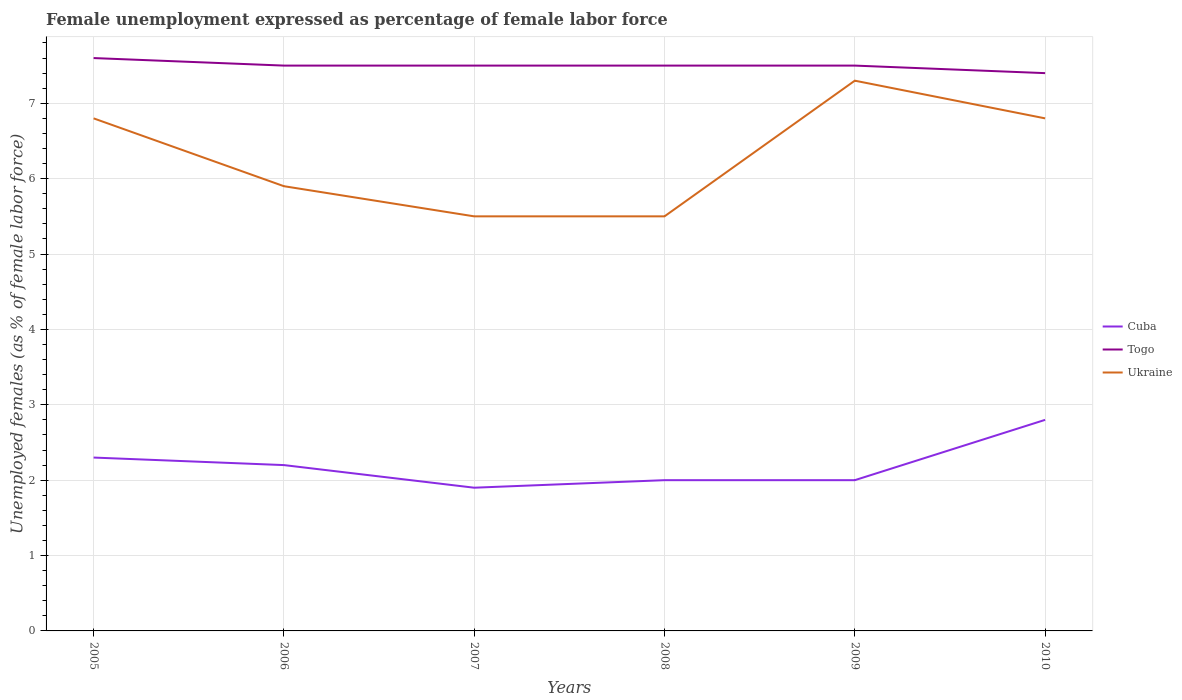How many different coloured lines are there?
Give a very brief answer. 3. Does the line corresponding to Ukraine intersect with the line corresponding to Cuba?
Provide a succinct answer. No. Is the number of lines equal to the number of legend labels?
Keep it short and to the point. Yes. What is the total unemployment in females in in Ukraine in the graph?
Give a very brief answer. 0.9. What is the difference between the highest and the second highest unemployment in females in in Togo?
Provide a succinct answer. 0.2. What is the difference between the highest and the lowest unemployment in females in in Cuba?
Your answer should be compact. 3. How many years are there in the graph?
Your answer should be very brief. 6. What is the difference between two consecutive major ticks on the Y-axis?
Give a very brief answer. 1. Does the graph contain any zero values?
Provide a short and direct response. No. Does the graph contain grids?
Provide a short and direct response. Yes. Where does the legend appear in the graph?
Provide a succinct answer. Center right. How many legend labels are there?
Offer a terse response. 3. How are the legend labels stacked?
Provide a short and direct response. Vertical. What is the title of the graph?
Offer a terse response. Female unemployment expressed as percentage of female labor force. Does "Brazil" appear as one of the legend labels in the graph?
Make the answer very short. No. What is the label or title of the X-axis?
Provide a succinct answer. Years. What is the label or title of the Y-axis?
Ensure brevity in your answer.  Unemployed females (as % of female labor force). What is the Unemployed females (as % of female labor force) in Cuba in 2005?
Make the answer very short. 2.3. What is the Unemployed females (as % of female labor force) of Togo in 2005?
Your response must be concise. 7.6. What is the Unemployed females (as % of female labor force) of Ukraine in 2005?
Keep it short and to the point. 6.8. What is the Unemployed females (as % of female labor force) in Cuba in 2006?
Provide a short and direct response. 2.2. What is the Unemployed females (as % of female labor force) in Ukraine in 2006?
Provide a succinct answer. 5.9. What is the Unemployed females (as % of female labor force) in Cuba in 2007?
Your response must be concise. 1.9. What is the Unemployed females (as % of female labor force) of Togo in 2007?
Offer a very short reply. 7.5. What is the Unemployed females (as % of female labor force) of Cuba in 2008?
Ensure brevity in your answer.  2. What is the Unemployed females (as % of female labor force) of Ukraine in 2008?
Ensure brevity in your answer.  5.5. What is the Unemployed females (as % of female labor force) of Cuba in 2009?
Your answer should be compact. 2. What is the Unemployed females (as % of female labor force) in Ukraine in 2009?
Your answer should be compact. 7.3. What is the Unemployed females (as % of female labor force) of Cuba in 2010?
Offer a very short reply. 2.8. What is the Unemployed females (as % of female labor force) of Togo in 2010?
Your answer should be very brief. 7.4. What is the Unemployed females (as % of female labor force) of Ukraine in 2010?
Offer a terse response. 6.8. Across all years, what is the maximum Unemployed females (as % of female labor force) in Cuba?
Offer a very short reply. 2.8. Across all years, what is the maximum Unemployed females (as % of female labor force) of Togo?
Provide a succinct answer. 7.6. Across all years, what is the maximum Unemployed females (as % of female labor force) in Ukraine?
Your response must be concise. 7.3. Across all years, what is the minimum Unemployed females (as % of female labor force) in Cuba?
Provide a succinct answer. 1.9. Across all years, what is the minimum Unemployed females (as % of female labor force) of Togo?
Your answer should be compact. 7.4. Across all years, what is the minimum Unemployed females (as % of female labor force) of Ukraine?
Your answer should be compact. 5.5. What is the total Unemployed females (as % of female labor force) of Ukraine in the graph?
Provide a succinct answer. 37.8. What is the difference between the Unemployed females (as % of female labor force) of Cuba in 2005 and that in 2007?
Make the answer very short. 0.4. What is the difference between the Unemployed females (as % of female labor force) of Togo in 2005 and that in 2007?
Ensure brevity in your answer.  0.1. What is the difference between the Unemployed females (as % of female labor force) of Togo in 2005 and that in 2008?
Make the answer very short. 0.1. What is the difference between the Unemployed females (as % of female labor force) of Ukraine in 2005 and that in 2009?
Provide a short and direct response. -0.5. What is the difference between the Unemployed females (as % of female labor force) of Cuba in 2005 and that in 2010?
Your answer should be compact. -0.5. What is the difference between the Unemployed females (as % of female labor force) in Ukraine in 2005 and that in 2010?
Your answer should be very brief. 0. What is the difference between the Unemployed females (as % of female labor force) of Cuba in 2006 and that in 2007?
Your answer should be compact. 0.3. What is the difference between the Unemployed females (as % of female labor force) in Togo in 2006 and that in 2007?
Offer a very short reply. 0. What is the difference between the Unemployed females (as % of female labor force) of Ukraine in 2006 and that in 2008?
Provide a succinct answer. 0.4. What is the difference between the Unemployed females (as % of female labor force) of Togo in 2006 and that in 2009?
Your response must be concise. 0. What is the difference between the Unemployed females (as % of female labor force) of Ukraine in 2006 and that in 2009?
Provide a succinct answer. -1.4. What is the difference between the Unemployed females (as % of female labor force) in Cuba in 2006 and that in 2010?
Make the answer very short. -0.6. What is the difference between the Unemployed females (as % of female labor force) of Cuba in 2007 and that in 2008?
Keep it short and to the point. -0.1. What is the difference between the Unemployed females (as % of female labor force) in Ukraine in 2007 and that in 2008?
Provide a succinct answer. 0. What is the difference between the Unemployed females (as % of female labor force) in Togo in 2007 and that in 2009?
Ensure brevity in your answer.  0. What is the difference between the Unemployed females (as % of female labor force) of Cuba in 2007 and that in 2010?
Provide a succinct answer. -0.9. What is the difference between the Unemployed females (as % of female labor force) of Togo in 2007 and that in 2010?
Your response must be concise. 0.1. What is the difference between the Unemployed females (as % of female labor force) of Ukraine in 2007 and that in 2010?
Your response must be concise. -1.3. What is the difference between the Unemployed females (as % of female labor force) of Ukraine in 2008 and that in 2009?
Ensure brevity in your answer.  -1.8. What is the difference between the Unemployed females (as % of female labor force) in Cuba in 2008 and that in 2010?
Your answer should be very brief. -0.8. What is the difference between the Unemployed females (as % of female labor force) of Ukraine in 2008 and that in 2010?
Make the answer very short. -1.3. What is the difference between the Unemployed females (as % of female labor force) in Ukraine in 2009 and that in 2010?
Ensure brevity in your answer.  0.5. What is the difference between the Unemployed females (as % of female labor force) in Cuba in 2005 and the Unemployed females (as % of female labor force) in Togo in 2006?
Offer a very short reply. -5.2. What is the difference between the Unemployed females (as % of female labor force) of Cuba in 2005 and the Unemployed females (as % of female labor force) of Ukraine in 2006?
Your answer should be compact. -3.6. What is the difference between the Unemployed females (as % of female labor force) of Togo in 2005 and the Unemployed females (as % of female labor force) of Ukraine in 2006?
Offer a terse response. 1.7. What is the difference between the Unemployed females (as % of female labor force) in Togo in 2005 and the Unemployed females (as % of female labor force) in Ukraine in 2007?
Your response must be concise. 2.1. What is the difference between the Unemployed females (as % of female labor force) in Cuba in 2005 and the Unemployed females (as % of female labor force) in Ukraine in 2008?
Your answer should be compact. -3.2. What is the difference between the Unemployed females (as % of female labor force) in Cuba in 2005 and the Unemployed females (as % of female labor force) in Togo in 2009?
Your answer should be very brief. -5.2. What is the difference between the Unemployed females (as % of female labor force) in Cuba in 2005 and the Unemployed females (as % of female labor force) in Ukraine in 2009?
Ensure brevity in your answer.  -5. What is the difference between the Unemployed females (as % of female labor force) in Cuba in 2006 and the Unemployed females (as % of female labor force) in Togo in 2007?
Your answer should be compact. -5.3. What is the difference between the Unemployed females (as % of female labor force) of Cuba in 2006 and the Unemployed females (as % of female labor force) of Ukraine in 2007?
Provide a succinct answer. -3.3. What is the difference between the Unemployed females (as % of female labor force) in Cuba in 2006 and the Unemployed females (as % of female labor force) in Ukraine in 2008?
Offer a very short reply. -3.3. What is the difference between the Unemployed females (as % of female labor force) in Cuba in 2006 and the Unemployed females (as % of female labor force) in Ukraine in 2009?
Give a very brief answer. -5.1. What is the difference between the Unemployed females (as % of female labor force) in Cuba in 2006 and the Unemployed females (as % of female labor force) in Togo in 2010?
Make the answer very short. -5.2. What is the difference between the Unemployed females (as % of female labor force) of Togo in 2007 and the Unemployed females (as % of female labor force) of Ukraine in 2008?
Provide a short and direct response. 2. What is the difference between the Unemployed females (as % of female labor force) of Cuba in 2007 and the Unemployed females (as % of female labor force) of Togo in 2009?
Offer a very short reply. -5.6. What is the difference between the Unemployed females (as % of female labor force) in Cuba in 2007 and the Unemployed females (as % of female labor force) in Ukraine in 2009?
Keep it short and to the point. -5.4. What is the difference between the Unemployed females (as % of female labor force) in Cuba in 2007 and the Unemployed females (as % of female labor force) in Ukraine in 2010?
Keep it short and to the point. -4.9. What is the difference between the Unemployed females (as % of female labor force) in Togo in 2007 and the Unemployed females (as % of female labor force) in Ukraine in 2010?
Provide a short and direct response. 0.7. What is the difference between the Unemployed females (as % of female labor force) in Cuba in 2008 and the Unemployed females (as % of female labor force) in Togo in 2009?
Make the answer very short. -5.5. What is the difference between the Unemployed females (as % of female labor force) of Cuba in 2008 and the Unemployed females (as % of female labor force) of Ukraine in 2009?
Provide a short and direct response. -5.3. What is the difference between the Unemployed females (as % of female labor force) in Cuba in 2009 and the Unemployed females (as % of female labor force) in Togo in 2010?
Your response must be concise. -5.4. What is the average Unemployed females (as % of female labor force) in Togo per year?
Keep it short and to the point. 7.5. In the year 2005, what is the difference between the Unemployed females (as % of female labor force) in Cuba and Unemployed females (as % of female labor force) in Togo?
Your answer should be compact. -5.3. In the year 2005, what is the difference between the Unemployed females (as % of female labor force) in Cuba and Unemployed females (as % of female labor force) in Ukraine?
Your response must be concise. -4.5. In the year 2006, what is the difference between the Unemployed females (as % of female labor force) in Cuba and Unemployed females (as % of female labor force) in Togo?
Your response must be concise. -5.3. In the year 2006, what is the difference between the Unemployed females (as % of female labor force) of Togo and Unemployed females (as % of female labor force) of Ukraine?
Offer a terse response. 1.6. In the year 2007, what is the difference between the Unemployed females (as % of female labor force) of Togo and Unemployed females (as % of female labor force) of Ukraine?
Give a very brief answer. 2. In the year 2008, what is the difference between the Unemployed females (as % of female labor force) of Cuba and Unemployed females (as % of female labor force) of Ukraine?
Offer a very short reply. -3.5. In the year 2009, what is the difference between the Unemployed females (as % of female labor force) in Cuba and Unemployed females (as % of female labor force) in Togo?
Offer a terse response. -5.5. In the year 2010, what is the difference between the Unemployed females (as % of female labor force) in Cuba and Unemployed females (as % of female labor force) in Togo?
Your response must be concise. -4.6. In the year 2010, what is the difference between the Unemployed females (as % of female labor force) of Togo and Unemployed females (as % of female labor force) of Ukraine?
Keep it short and to the point. 0.6. What is the ratio of the Unemployed females (as % of female labor force) of Cuba in 2005 to that in 2006?
Your answer should be very brief. 1.05. What is the ratio of the Unemployed females (as % of female labor force) of Togo in 2005 to that in 2006?
Provide a succinct answer. 1.01. What is the ratio of the Unemployed females (as % of female labor force) of Ukraine in 2005 to that in 2006?
Give a very brief answer. 1.15. What is the ratio of the Unemployed females (as % of female labor force) in Cuba in 2005 to that in 2007?
Offer a very short reply. 1.21. What is the ratio of the Unemployed females (as % of female labor force) of Togo in 2005 to that in 2007?
Your response must be concise. 1.01. What is the ratio of the Unemployed females (as % of female labor force) of Ukraine in 2005 to that in 2007?
Provide a succinct answer. 1.24. What is the ratio of the Unemployed females (as % of female labor force) of Cuba in 2005 to that in 2008?
Provide a short and direct response. 1.15. What is the ratio of the Unemployed females (as % of female labor force) in Togo in 2005 to that in 2008?
Make the answer very short. 1.01. What is the ratio of the Unemployed females (as % of female labor force) in Ukraine in 2005 to that in 2008?
Ensure brevity in your answer.  1.24. What is the ratio of the Unemployed females (as % of female labor force) of Cuba in 2005 to that in 2009?
Your response must be concise. 1.15. What is the ratio of the Unemployed females (as % of female labor force) in Togo in 2005 to that in 2009?
Provide a succinct answer. 1.01. What is the ratio of the Unemployed females (as % of female labor force) of Ukraine in 2005 to that in 2009?
Your answer should be very brief. 0.93. What is the ratio of the Unemployed females (as % of female labor force) in Cuba in 2005 to that in 2010?
Offer a terse response. 0.82. What is the ratio of the Unemployed females (as % of female labor force) of Cuba in 2006 to that in 2007?
Give a very brief answer. 1.16. What is the ratio of the Unemployed females (as % of female labor force) of Ukraine in 2006 to that in 2007?
Offer a terse response. 1.07. What is the ratio of the Unemployed females (as % of female labor force) of Cuba in 2006 to that in 2008?
Keep it short and to the point. 1.1. What is the ratio of the Unemployed females (as % of female labor force) in Ukraine in 2006 to that in 2008?
Provide a succinct answer. 1.07. What is the ratio of the Unemployed females (as % of female labor force) of Ukraine in 2006 to that in 2009?
Offer a very short reply. 0.81. What is the ratio of the Unemployed females (as % of female labor force) of Cuba in 2006 to that in 2010?
Offer a terse response. 0.79. What is the ratio of the Unemployed females (as % of female labor force) in Togo in 2006 to that in 2010?
Make the answer very short. 1.01. What is the ratio of the Unemployed females (as % of female labor force) in Ukraine in 2006 to that in 2010?
Offer a terse response. 0.87. What is the ratio of the Unemployed females (as % of female labor force) in Togo in 2007 to that in 2008?
Offer a very short reply. 1. What is the ratio of the Unemployed females (as % of female labor force) in Ukraine in 2007 to that in 2008?
Make the answer very short. 1. What is the ratio of the Unemployed females (as % of female labor force) of Ukraine in 2007 to that in 2009?
Your response must be concise. 0.75. What is the ratio of the Unemployed females (as % of female labor force) of Cuba in 2007 to that in 2010?
Your response must be concise. 0.68. What is the ratio of the Unemployed females (as % of female labor force) of Togo in 2007 to that in 2010?
Make the answer very short. 1.01. What is the ratio of the Unemployed females (as % of female labor force) in Ukraine in 2007 to that in 2010?
Ensure brevity in your answer.  0.81. What is the ratio of the Unemployed females (as % of female labor force) in Togo in 2008 to that in 2009?
Make the answer very short. 1. What is the ratio of the Unemployed females (as % of female labor force) in Ukraine in 2008 to that in 2009?
Ensure brevity in your answer.  0.75. What is the ratio of the Unemployed females (as % of female labor force) of Togo in 2008 to that in 2010?
Your answer should be very brief. 1.01. What is the ratio of the Unemployed females (as % of female labor force) in Ukraine in 2008 to that in 2010?
Provide a succinct answer. 0.81. What is the ratio of the Unemployed females (as % of female labor force) in Cuba in 2009 to that in 2010?
Make the answer very short. 0.71. What is the ratio of the Unemployed females (as % of female labor force) of Togo in 2009 to that in 2010?
Your answer should be very brief. 1.01. What is the ratio of the Unemployed females (as % of female labor force) in Ukraine in 2009 to that in 2010?
Your response must be concise. 1.07. What is the difference between the highest and the second highest Unemployed females (as % of female labor force) of Cuba?
Provide a succinct answer. 0.5. What is the difference between the highest and the second highest Unemployed females (as % of female labor force) of Ukraine?
Provide a short and direct response. 0.5. What is the difference between the highest and the lowest Unemployed females (as % of female labor force) in Cuba?
Your answer should be very brief. 0.9. What is the difference between the highest and the lowest Unemployed females (as % of female labor force) of Togo?
Make the answer very short. 0.2. 